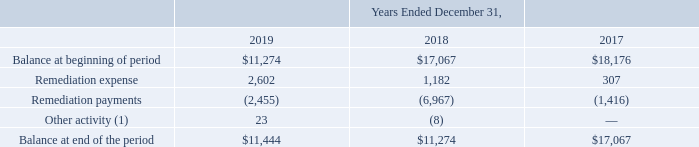NOTES TO CONSOLIDATED FINANCIAL STATEMENTS (in thousands, except for share and per share data)
NOTE 10 — Contingencies
Certain processes in the manufacture of our current and past products create by-products classified as hazardous waste. We have been notified by the U.S. Environmental Protection Agency, state environmental agencies, and in some cases, groups of potentially responsible parties, that we may be potentially liable for environmental contamination at several sites currently and formerly owned or operated by us. Two of those sites, Asheville, North Carolina and Mountain View, California, are designated National Priorities List sites under the U.S. Environmental Protection Agency’s Superfund program. We accrue a liability for probable remediation activities, claims and proceedings against us with respect to environmental matters if the amount can be reasonably estimated, and provide disclosures including the nature of a loss whenever it is probable or reasonably possible that a potentially material loss may have occurred but cannot be estimated. We record contingent loss accruals on an undiscounted basis.
A roll-forward of remediation reserves included in accrued expenses and other liabilities in the Consolidated Balance Sheets is comprised of the following:
(1) Other activity includes currency translation adjustments not recorded through remediation expense
Unrelated to the environmental claims described above, certain other legal claims are pending against us with respect to matters arising out of the ordinary conduct of our business.
We provide product warranties when we sell our products and accrue for estimated liabilities at the time of sale. Warranty estimates are forecasts based on the best available information and historical claims experience. We accrue for specific warranty claims if we believe that the facts of a specific claim make it probable that a liability in excess of our historical experience has been incurred, and provide disclosures for specific claims whenever it is reasonably possible that a material loss may be incurred which cannot be estimated. We have an outstanding warranty claim for which we have not yet determined the root cause of a product performance issue. Testing is ongoing. We are not able to quantify the potential impact on our operations, if any, because we have not yet determined the root cause.
We cannot provide assurance that the ultimate disposition of environmental, legal, and product warranty claims will not materially exceed the amount of our accrued losses and adversely impact our consolidated financial position, results of operations, or cash flows. Our accrued liabilities and disclosures will be adjusted accordingly if additional information becomes available in the future.
Which years does the table provide information for A roll-forward of remediation reserves included in accrued expenses and other liabilities in the Consolidated Balance Sheets? 2019, 2018, 2017. What did Other activity include? Currency translation adjustments not recorded through remediation expense. What were the Remediation payments in 2017?
Answer scale should be: thousand. (1,416). How many years did Remediation expense exceed $1,000 thousand? 2019##2018
Answer: 2. What was the change in Other activity between 2018 and 2019?
Answer scale should be: thousand. 23-(-8)
Answer: 31. What was the percentage change in the Balance at end of the period between 2018 and 2019?
Answer scale should be: percent. (11,444-11,274)/11,274
Answer: 1.51. 